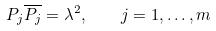<formula> <loc_0><loc_0><loc_500><loc_500>P _ { j } \overline { P _ { j } } = \lambda ^ { 2 } , \quad j = 1 , \dots , m</formula> 